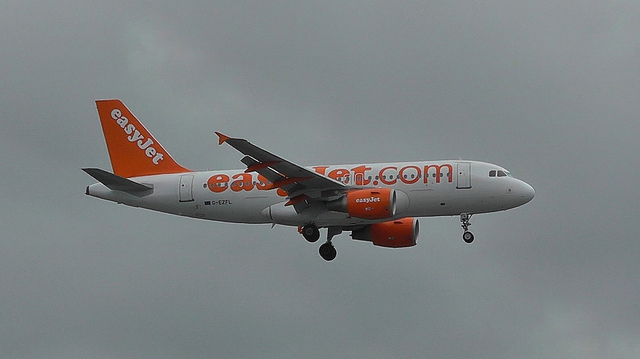Please identify all text content in this image. easyJet easjet.com EASYJET 